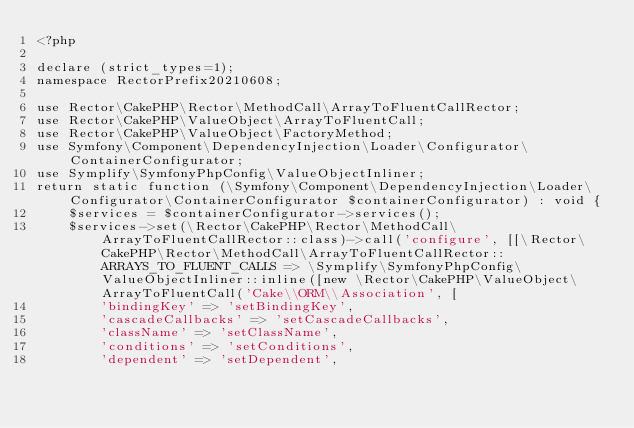Convert code to text. <code><loc_0><loc_0><loc_500><loc_500><_PHP_><?php

declare (strict_types=1);
namespace RectorPrefix20210608;

use Rector\CakePHP\Rector\MethodCall\ArrayToFluentCallRector;
use Rector\CakePHP\ValueObject\ArrayToFluentCall;
use Rector\CakePHP\ValueObject\FactoryMethod;
use Symfony\Component\DependencyInjection\Loader\Configurator\ContainerConfigurator;
use Symplify\SymfonyPhpConfig\ValueObjectInliner;
return static function (\Symfony\Component\DependencyInjection\Loader\Configurator\ContainerConfigurator $containerConfigurator) : void {
    $services = $containerConfigurator->services();
    $services->set(\Rector\CakePHP\Rector\MethodCall\ArrayToFluentCallRector::class)->call('configure', [[\Rector\CakePHP\Rector\MethodCall\ArrayToFluentCallRector::ARRAYS_TO_FLUENT_CALLS => \Symplify\SymfonyPhpConfig\ValueObjectInliner::inline([new \Rector\CakePHP\ValueObject\ArrayToFluentCall('Cake\\ORM\\Association', [
        'bindingKey' => 'setBindingKey',
        'cascadeCallbacks' => 'setCascadeCallbacks',
        'className' => 'setClassName',
        'conditions' => 'setConditions',
        'dependent' => 'setDependent',</code> 